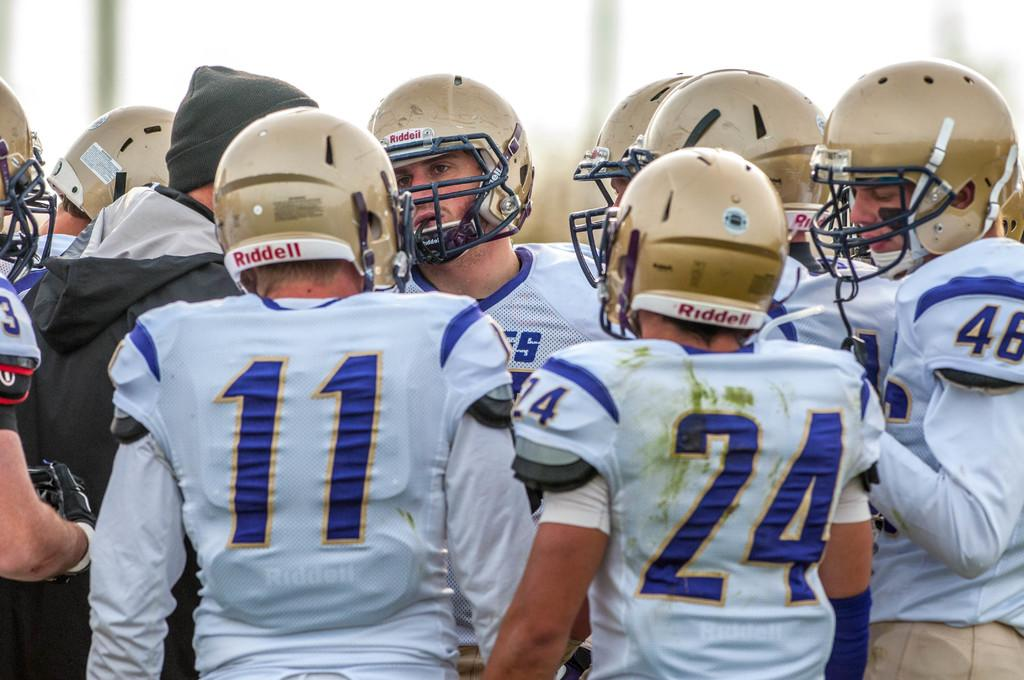What are the men in the foreground of the image wearing? The men in the foreground of the image are wearing white dresses and helmets. Can you describe the appearance of the man in the foreground who is not wearing white? The man in the foreground who is not wearing white is wearing a black coat and a black cap. What can be observed about the background of the image? The background of the image is blurred. What type of zinc is present in the image? There is no zinc present in the image. How does the sand appear in the image? There is no sand present in the image. 